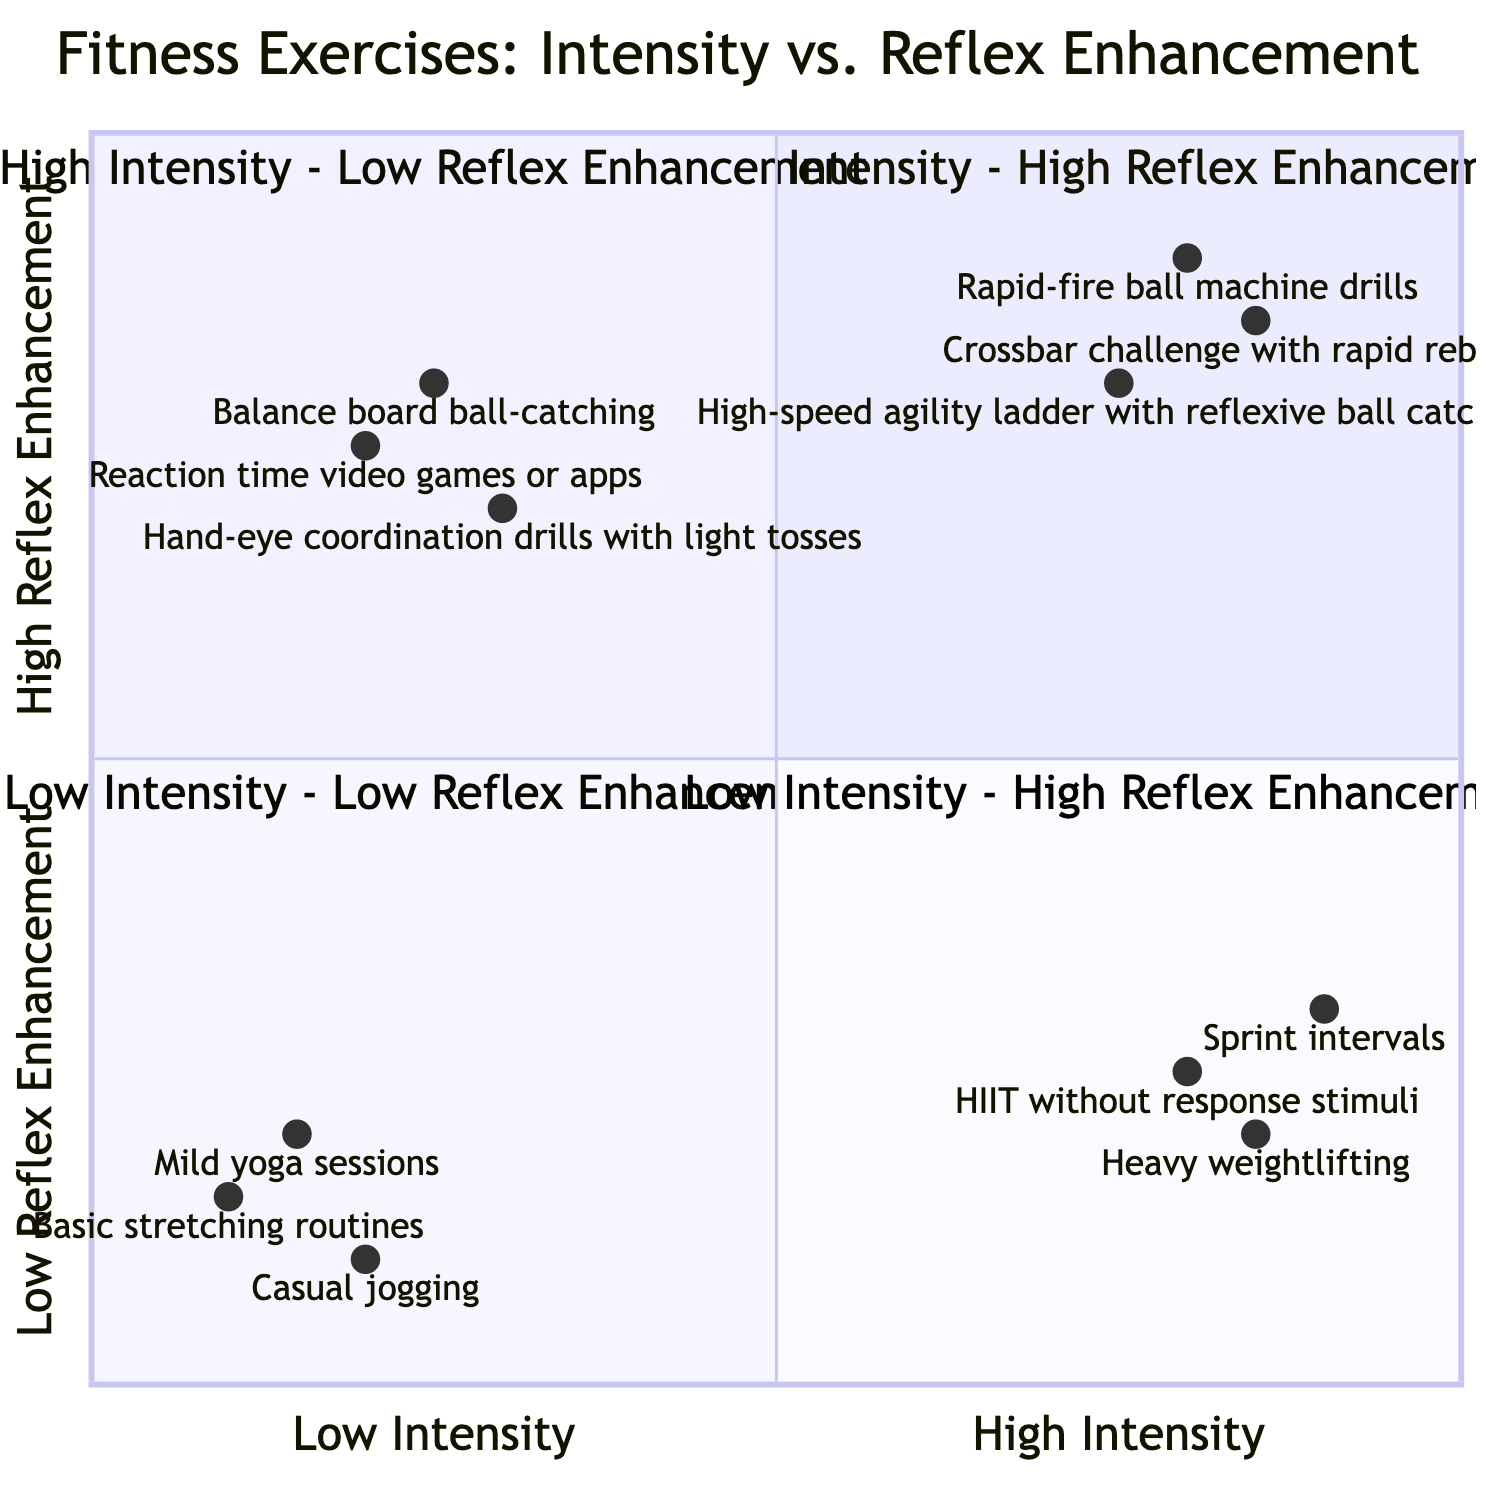What exercises are in the High Intensity - High Reflex Enhancement quadrant? The High Intensity - High Reflex Enhancement quadrant is defined by high intensity on the x-axis and high reflex enhancement on the y-axis. The listed exercises include Rapid-fire ball machine drills, Crossbar challenge with rapid rebounds, and High-speed agility ladder with reflexive ball catching.
Answer: Rapid-fire ball machine drills, Crossbar challenge with rapid rebounds, High-speed agility ladder with reflexive ball catching How many exercises are in the Low Intensity - Low Reflex Enhancement quadrant? The Low Intensity - Low Reflex Enhancement quadrant contains three exercises: Casual jogging, Basic stretching routines, and Mild yoga sessions.
Answer: 3 Which quadrant contains HIIT without response stimuli? HIIT without response stimuli is identified in the High Intensity - Low Reflex Enhancement quadrant, where the intensity is high, but reflex enhancement is low.
Answer: High Intensity - Low Reflex Enhancement What is the reflex enhancement level of the Balance board ball-catching exercise? The Balance board ball-catching exercise is located in the Low Intensity - High Reflex Enhancement quadrant. Its reflex enhancement level is measured at 0.8 on the y-axis.
Answer: 0.8 Provide an exercise that has high intensity but low reflex enhancement. The exercises in the High Intensity - Low Reflex Enhancement quadrant include Sprint intervals, Heavy weightlifting, and HIIT without response stimuli. One example from this group is Sprint intervals.
Answer: Sprint intervals Which quadrant has the least intense exercises? The quadrant with the least intense exercises is the Low Intensity - Low Reflex Enhancement quadrant, where both intensity and reflex enhancement are low.
Answer: Low Intensity - Low Reflex Enhancement What is the highest reflex enhancement exercise listed in this chart? The exercise with the highest reflex enhancement is the Rapid-fire ball machine drills, located in the High Intensity - High Reflex Enhancement quadrant, where reflex enhancement is at 0.9.
Answer: Rapid-fire ball machine drills How many exercises focus on reflex enhancement without adding significant intensity? The exercises focused on reflex enhancement without significant intensity can be found in the Low Intensity - High Reflex Enhancement quadrant, which contains three exercises: Hand-eye coordination drills with light tosses, Reaction time video games or apps, and Balance board ball-catching.
Answer: 3 What is the intensity level of Heavy weightlifting? Heavy weightlifting is categorized under the High Intensity - Low Reflex Enhancement quadrant, where its intensity level is 0.85 on the x-axis.
Answer: 0.85 